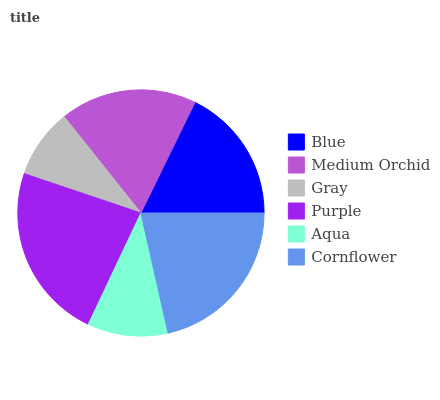Is Gray the minimum?
Answer yes or no. Yes. Is Purple the maximum?
Answer yes or no. Yes. Is Medium Orchid the minimum?
Answer yes or no. No. Is Medium Orchid the maximum?
Answer yes or no. No. Is Medium Orchid greater than Blue?
Answer yes or no. Yes. Is Blue less than Medium Orchid?
Answer yes or no. Yes. Is Blue greater than Medium Orchid?
Answer yes or no. No. Is Medium Orchid less than Blue?
Answer yes or no. No. Is Medium Orchid the high median?
Answer yes or no. Yes. Is Blue the low median?
Answer yes or no. Yes. Is Aqua the high median?
Answer yes or no. No. Is Aqua the low median?
Answer yes or no. No. 